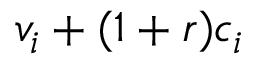Convert formula to latex. <formula><loc_0><loc_0><loc_500><loc_500>v _ { i } + ( 1 + r ) c _ { i }</formula> 